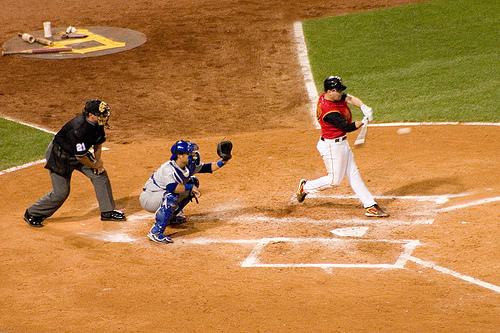Is this a professional baseball team?
Give a very brief answer. Yes. Why are two of these three men wearing face masks?
Concise answer only. Safety. Does the batter have a stripe on his pants?
Concise answer only. Yes. 